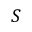Convert formula to latex. <formula><loc_0><loc_0><loc_500><loc_500>S</formula> 